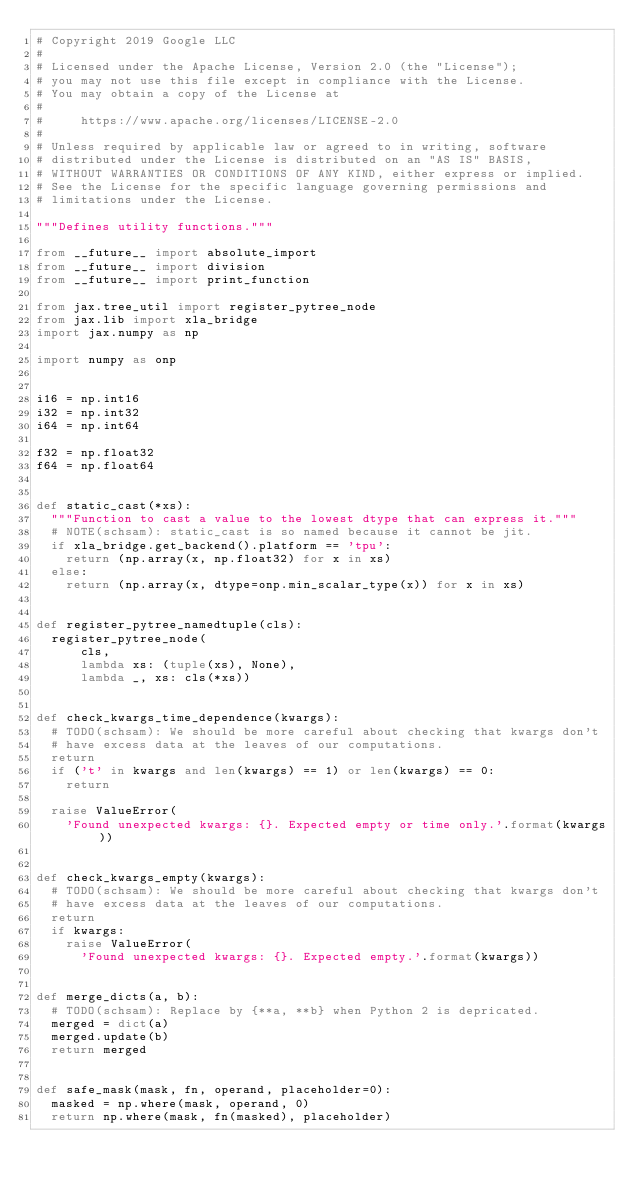<code> <loc_0><loc_0><loc_500><loc_500><_Python_># Copyright 2019 Google LLC
#
# Licensed under the Apache License, Version 2.0 (the "License");
# you may not use this file except in compliance with the License.
# You may obtain a copy of the License at
#
#     https://www.apache.org/licenses/LICENSE-2.0
#
# Unless required by applicable law or agreed to in writing, software
# distributed under the License is distributed on an "AS IS" BASIS,
# WITHOUT WARRANTIES OR CONDITIONS OF ANY KIND, either express or implied.
# See the License for the specific language governing permissions and
# limitations under the License.

"""Defines utility functions."""

from __future__ import absolute_import
from __future__ import division
from __future__ import print_function

from jax.tree_util import register_pytree_node
from jax.lib import xla_bridge
import jax.numpy as np

import numpy as onp


i16 = np.int16
i32 = np.int32
i64 = np.int64

f32 = np.float32
f64 = np.float64


def static_cast(*xs):
  """Function to cast a value to the lowest dtype that can express it."""
  # NOTE(schsam): static_cast is so named because it cannot be jit.
  if xla_bridge.get_backend().platform == 'tpu':
    return (np.array(x, np.float32) for x in xs)
  else:
    return (np.array(x, dtype=onp.min_scalar_type(x)) for x in xs)


def register_pytree_namedtuple(cls):
  register_pytree_node(
      cls,
      lambda xs: (tuple(xs), None),
      lambda _, xs: cls(*xs))


def check_kwargs_time_dependence(kwargs):
  # TODO(schsam): We should be more careful about checking that kwargs don't
  # have excess data at the leaves of our computations.
  return
  if ('t' in kwargs and len(kwargs) == 1) or len(kwargs) == 0:
    return

  raise ValueError(
    'Found unexpected kwargs: {}. Expected empty or time only.'.format(kwargs))


def check_kwargs_empty(kwargs):
  # TODO(schsam): We should be more careful about checking that kwargs don't
  # have excess data at the leaves of our computations.
  return
  if kwargs:
    raise ValueError(
      'Found unexpected kwargs: {}. Expected empty.'.format(kwargs))


def merge_dicts(a, b):
  # TODO(schsam): Replace by {**a, **b} when Python 2 is depricated.
  merged = dict(a)
  merged.update(b)
  return merged


def safe_mask(mask, fn, operand, placeholder=0):
  masked = np.where(mask, operand, 0)
  return np.where(mask, fn(masked), placeholder)
</code> 